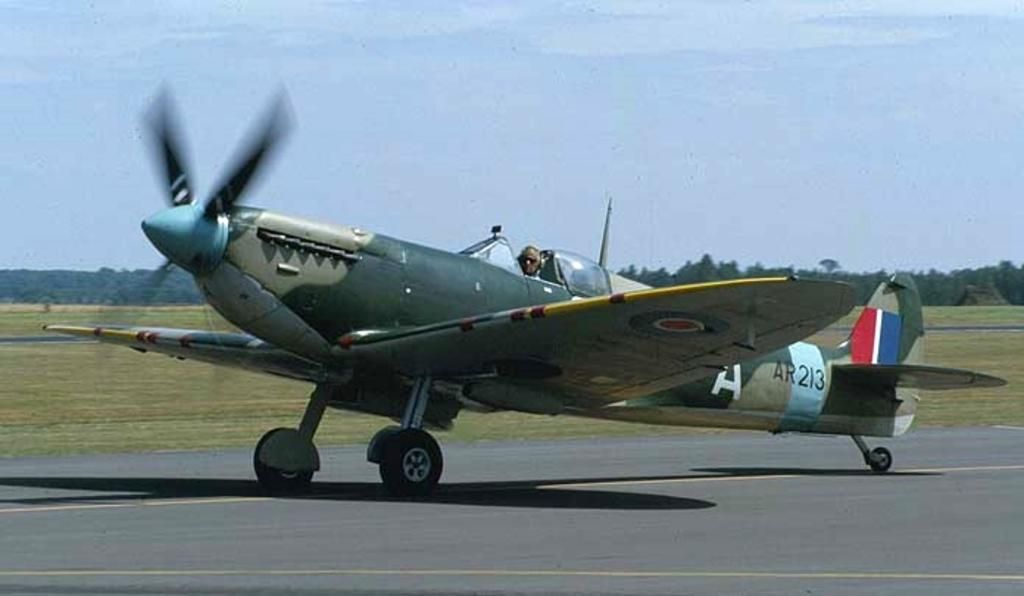<image>
Relay a brief, clear account of the picture shown. A small plane with the letter A towards its tail. 